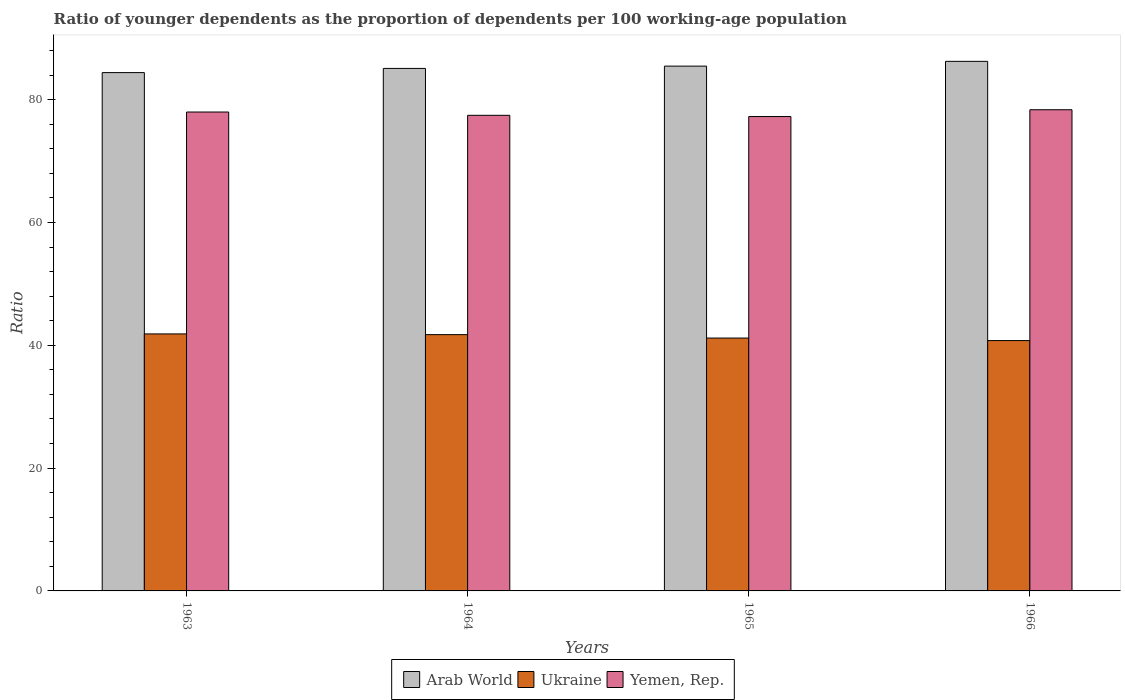How many different coloured bars are there?
Offer a very short reply. 3. How many groups of bars are there?
Offer a terse response. 4. Are the number of bars on each tick of the X-axis equal?
Your response must be concise. Yes. How many bars are there on the 4th tick from the left?
Offer a very short reply. 3. How many bars are there on the 4th tick from the right?
Provide a succinct answer. 3. What is the label of the 3rd group of bars from the left?
Provide a succinct answer. 1965. What is the age dependency ratio(young) in Yemen, Rep. in 1966?
Offer a terse response. 78.37. Across all years, what is the maximum age dependency ratio(young) in Arab World?
Provide a succinct answer. 86.25. Across all years, what is the minimum age dependency ratio(young) in Ukraine?
Offer a very short reply. 40.77. In which year was the age dependency ratio(young) in Ukraine maximum?
Offer a very short reply. 1963. In which year was the age dependency ratio(young) in Arab World minimum?
Your answer should be compact. 1963. What is the total age dependency ratio(young) in Arab World in the graph?
Give a very brief answer. 341.23. What is the difference between the age dependency ratio(young) in Arab World in 1964 and that in 1966?
Offer a terse response. -1.15. What is the difference between the age dependency ratio(young) in Arab World in 1965 and the age dependency ratio(young) in Ukraine in 1966?
Offer a terse response. 44.7. What is the average age dependency ratio(young) in Ukraine per year?
Your answer should be very brief. 41.39. In the year 1966, what is the difference between the age dependency ratio(young) in Yemen, Rep. and age dependency ratio(young) in Arab World?
Provide a succinct answer. -7.88. In how many years, is the age dependency ratio(young) in Ukraine greater than 4?
Ensure brevity in your answer.  4. What is the ratio of the age dependency ratio(young) in Ukraine in 1964 to that in 1966?
Keep it short and to the point. 1.02. Is the age dependency ratio(young) in Ukraine in 1965 less than that in 1966?
Provide a short and direct response. No. What is the difference between the highest and the second highest age dependency ratio(young) in Ukraine?
Your answer should be compact. 0.12. What is the difference between the highest and the lowest age dependency ratio(young) in Arab World?
Your answer should be very brief. 1.83. In how many years, is the age dependency ratio(young) in Ukraine greater than the average age dependency ratio(young) in Ukraine taken over all years?
Your response must be concise. 2. Is the sum of the age dependency ratio(young) in Arab World in 1963 and 1966 greater than the maximum age dependency ratio(young) in Yemen, Rep. across all years?
Your answer should be very brief. Yes. What does the 3rd bar from the left in 1965 represents?
Provide a short and direct response. Yemen, Rep. What does the 2nd bar from the right in 1964 represents?
Provide a succinct answer. Ukraine. How many bars are there?
Your answer should be compact. 12. How many years are there in the graph?
Provide a succinct answer. 4. What is the difference between two consecutive major ticks on the Y-axis?
Offer a very short reply. 20. Are the values on the major ticks of Y-axis written in scientific E-notation?
Keep it short and to the point. No. Does the graph contain grids?
Offer a very short reply. No. Where does the legend appear in the graph?
Your response must be concise. Bottom center. What is the title of the graph?
Give a very brief answer. Ratio of younger dependents as the proportion of dependents per 100 working-age population. What is the label or title of the X-axis?
Your answer should be very brief. Years. What is the label or title of the Y-axis?
Provide a succinct answer. Ratio. What is the Ratio in Arab World in 1963?
Your answer should be very brief. 84.41. What is the Ratio in Ukraine in 1963?
Make the answer very short. 41.86. What is the Ratio in Yemen, Rep. in 1963?
Provide a short and direct response. 77.99. What is the Ratio of Arab World in 1964?
Your answer should be very brief. 85.1. What is the Ratio of Ukraine in 1964?
Your response must be concise. 41.74. What is the Ratio of Yemen, Rep. in 1964?
Provide a short and direct response. 77.46. What is the Ratio in Arab World in 1965?
Give a very brief answer. 85.47. What is the Ratio of Ukraine in 1965?
Make the answer very short. 41.18. What is the Ratio of Yemen, Rep. in 1965?
Ensure brevity in your answer.  77.26. What is the Ratio of Arab World in 1966?
Provide a succinct answer. 86.25. What is the Ratio in Ukraine in 1966?
Your response must be concise. 40.77. What is the Ratio of Yemen, Rep. in 1966?
Keep it short and to the point. 78.37. Across all years, what is the maximum Ratio of Arab World?
Make the answer very short. 86.25. Across all years, what is the maximum Ratio of Ukraine?
Your answer should be very brief. 41.86. Across all years, what is the maximum Ratio of Yemen, Rep.?
Provide a succinct answer. 78.37. Across all years, what is the minimum Ratio in Arab World?
Offer a terse response. 84.41. Across all years, what is the minimum Ratio of Ukraine?
Keep it short and to the point. 40.77. Across all years, what is the minimum Ratio in Yemen, Rep.?
Offer a terse response. 77.26. What is the total Ratio of Arab World in the graph?
Offer a terse response. 341.23. What is the total Ratio of Ukraine in the graph?
Your answer should be compact. 165.55. What is the total Ratio in Yemen, Rep. in the graph?
Offer a very short reply. 311.08. What is the difference between the Ratio in Arab World in 1963 and that in 1964?
Ensure brevity in your answer.  -0.68. What is the difference between the Ratio in Ukraine in 1963 and that in 1964?
Your answer should be compact. 0.12. What is the difference between the Ratio of Yemen, Rep. in 1963 and that in 1964?
Your response must be concise. 0.54. What is the difference between the Ratio in Arab World in 1963 and that in 1965?
Give a very brief answer. -1.06. What is the difference between the Ratio of Ukraine in 1963 and that in 1965?
Make the answer very short. 0.68. What is the difference between the Ratio in Yemen, Rep. in 1963 and that in 1965?
Your answer should be compact. 0.74. What is the difference between the Ratio of Arab World in 1963 and that in 1966?
Ensure brevity in your answer.  -1.83. What is the difference between the Ratio in Ukraine in 1963 and that in 1966?
Give a very brief answer. 1.09. What is the difference between the Ratio of Yemen, Rep. in 1963 and that in 1966?
Make the answer very short. -0.37. What is the difference between the Ratio in Arab World in 1964 and that in 1965?
Your answer should be very brief. -0.37. What is the difference between the Ratio of Ukraine in 1964 and that in 1965?
Provide a short and direct response. 0.56. What is the difference between the Ratio in Yemen, Rep. in 1964 and that in 1965?
Your response must be concise. 0.2. What is the difference between the Ratio in Arab World in 1964 and that in 1966?
Offer a very short reply. -1.15. What is the difference between the Ratio of Ukraine in 1964 and that in 1966?
Your answer should be compact. 0.97. What is the difference between the Ratio in Yemen, Rep. in 1964 and that in 1966?
Keep it short and to the point. -0.91. What is the difference between the Ratio in Arab World in 1965 and that in 1966?
Offer a very short reply. -0.78. What is the difference between the Ratio of Ukraine in 1965 and that in 1966?
Your answer should be compact. 0.41. What is the difference between the Ratio of Yemen, Rep. in 1965 and that in 1966?
Offer a very short reply. -1.11. What is the difference between the Ratio of Arab World in 1963 and the Ratio of Ukraine in 1964?
Make the answer very short. 42.67. What is the difference between the Ratio of Arab World in 1963 and the Ratio of Yemen, Rep. in 1964?
Your answer should be very brief. 6.96. What is the difference between the Ratio of Ukraine in 1963 and the Ratio of Yemen, Rep. in 1964?
Provide a succinct answer. -35.6. What is the difference between the Ratio of Arab World in 1963 and the Ratio of Ukraine in 1965?
Your response must be concise. 43.23. What is the difference between the Ratio of Arab World in 1963 and the Ratio of Yemen, Rep. in 1965?
Your answer should be very brief. 7.16. What is the difference between the Ratio in Ukraine in 1963 and the Ratio in Yemen, Rep. in 1965?
Ensure brevity in your answer.  -35.4. What is the difference between the Ratio of Arab World in 1963 and the Ratio of Ukraine in 1966?
Your response must be concise. 43.64. What is the difference between the Ratio in Arab World in 1963 and the Ratio in Yemen, Rep. in 1966?
Make the answer very short. 6.05. What is the difference between the Ratio of Ukraine in 1963 and the Ratio of Yemen, Rep. in 1966?
Provide a succinct answer. -36.51. What is the difference between the Ratio of Arab World in 1964 and the Ratio of Ukraine in 1965?
Offer a terse response. 43.91. What is the difference between the Ratio of Arab World in 1964 and the Ratio of Yemen, Rep. in 1965?
Provide a succinct answer. 7.84. What is the difference between the Ratio in Ukraine in 1964 and the Ratio in Yemen, Rep. in 1965?
Offer a terse response. -35.52. What is the difference between the Ratio of Arab World in 1964 and the Ratio of Ukraine in 1966?
Offer a terse response. 44.33. What is the difference between the Ratio of Arab World in 1964 and the Ratio of Yemen, Rep. in 1966?
Provide a short and direct response. 6.73. What is the difference between the Ratio in Ukraine in 1964 and the Ratio in Yemen, Rep. in 1966?
Give a very brief answer. -36.63. What is the difference between the Ratio in Arab World in 1965 and the Ratio in Ukraine in 1966?
Your answer should be very brief. 44.7. What is the difference between the Ratio of Arab World in 1965 and the Ratio of Yemen, Rep. in 1966?
Give a very brief answer. 7.1. What is the difference between the Ratio of Ukraine in 1965 and the Ratio of Yemen, Rep. in 1966?
Provide a short and direct response. -37.18. What is the average Ratio in Arab World per year?
Offer a terse response. 85.31. What is the average Ratio of Ukraine per year?
Offer a terse response. 41.39. What is the average Ratio of Yemen, Rep. per year?
Keep it short and to the point. 77.77. In the year 1963, what is the difference between the Ratio in Arab World and Ratio in Ukraine?
Ensure brevity in your answer.  42.56. In the year 1963, what is the difference between the Ratio in Arab World and Ratio in Yemen, Rep.?
Ensure brevity in your answer.  6.42. In the year 1963, what is the difference between the Ratio of Ukraine and Ratio of Yemen, Rep.?
Offer a very short reply. -36.14. In the year 1964, what is the difference between the Ratio of Arab World and Ratio of Ukraine?
Your response must be concise. 43.36. In the year 1964, what is the difference between the Ratio in Arab World and Ratio in Yemen, Rep.?
Keep it short and to the point. 7.64. In the year 1964, what is the difference between the Ratio of Ukraine and Ratio of Yemen, Rep.?
Keep it short and to the point. -35.72. In the year 1965, what is the difference between the Ratio of Arab World and Ratio of Ukraine?
Your answer should be compact. 44.29. In the year 1965, what is the difference between the Ratio of Arab World and Ratio of Yemen, Rep.?
Your answer should be very brief. 8.21. In the year 1965, what is the difference between the Ratio of Ukraine and Ratio of Yemen, Rep.?
Offer a terse response. -36.08. In the year 1966, what is the difference between the Ratio of Arab World and Ratio of Ukraine?
Your answer should be very brief. 45.47. In the year 1966, what is the difference between the Ratio of Arab World and Ratio of Yemen, Rep.?
Your answer should be very brief. 7.88. In the year 1966, what is the difference between the Ratio of Ukraine and Ratio of Yemen, Rep.?
Your answer should be very brief. -37.59. What is the ratio of the Ratio in Ukraine in 1963 to that in 1964?
Offer a very short reply. 1. What is the ratio of the Ratio of Arab World in 1963 to that in 1965?
Your response must be concise. 0.99. What is the ratio of the Ratio of Ukraine in 1963 to that in 1965?
Provide a succinct answer. 1.02. What is the ratio of the Ratio in Yemen, Rep. in 1963 to that in 1965?
Your answer should be very brief. 1.01. What is the ratio of the Ratio of Arab World in 1963 to that in 1966?
Provide a succinct answer. 0.98. What is the ratio of the Ratio in Ukraine in 1963 to that in 1966?
Ensure brevity in your answer.  1.03. What is the ratio of the Ratio of Yemen, Rep. in 1963 to that in 1966?
Keep it short and to the point. 1. What is the ratio of the Ratio of Arab World in 1964 to that in 1965?
Provide a short and direct response. 1. What is the ratio of the Ratio of Ukraine in 1964 to that in 1965?
Your answer should be compact. 1.01. What is the ratio of the Ratio in Yemen, Rep. in 1964 to that in 1965?
Your answer should be very brief. 1. What is the ratio of the Ratio in Arab World in 1964 to that in 1966?
Keep it short and to the point. 0.99. What is the ratio of the Ratio in Ukraine in 1964 to that in 1966?
Provide a short and direct response. 1.02. What is the ratio of the Ratio of Yemen, Rep. in 1964 to that in 1966?
Your answer should be compact. 0.99. What is the ratio of the Ratio in Arab World in 1965 to that in 1966?
Your answer should be very brief. 0.99. What is the ratio of the Ratio of Yemen, Rep. in 1965 to that in 1966?
Provide a short and direct response. 0.99. What is the difference between the highest and the second highest Ratio in Arab World?
Your response must be concise. 0.78. What is the difference between the highest and the second highest Ratio of Ukraine?
Your answer should be very brief. 0.12. What is the difference between the highest and the second highest Ratio in Yemen, Rep.?
Offer a terse response. 0.37. What is the difference between the highest and the lowest Ratio of Arab World?
Ensure brevity in your answer.  1.83. What is the difference between the highest and the lowest Ratio of Ukraine?
Provide a succinct answer. 1.09. What is the difference between the highest and the lowest Ratio in Yemen, Rep.?
Give a very brief answer. 1.11. 